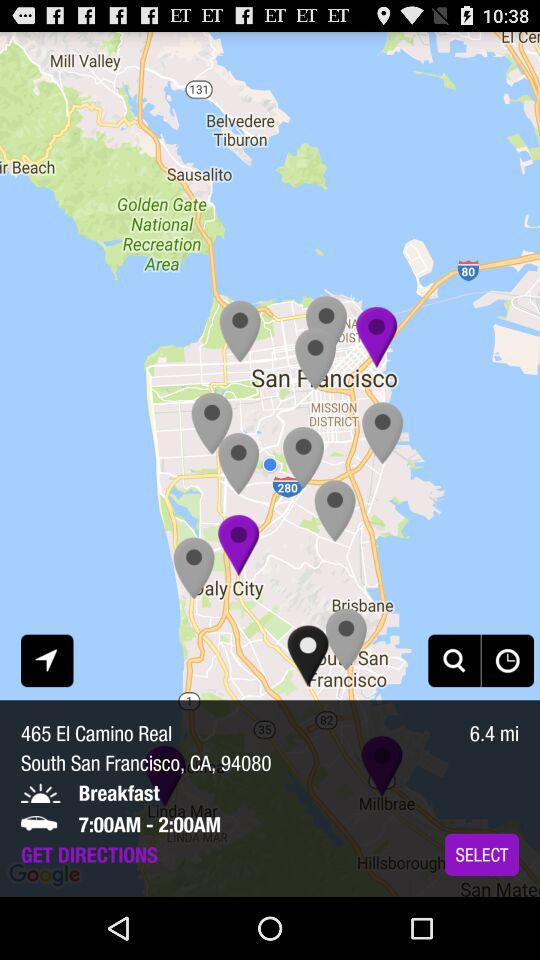What is the distance? The distance is 6.4 miles. 